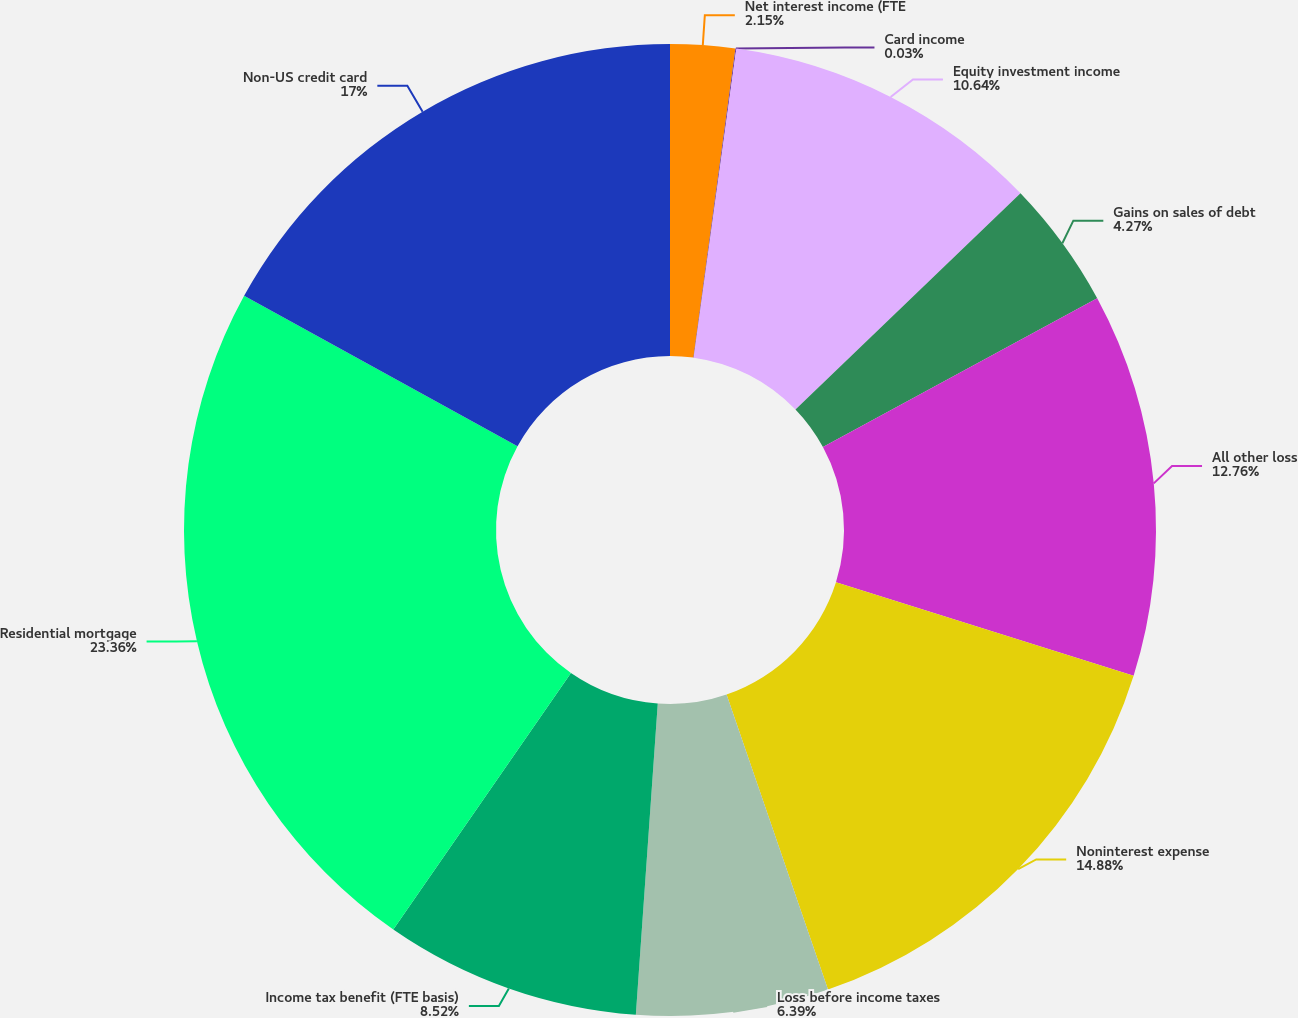Convert chart. <chart><loc_0><loc_0><loc_500><loc_500><pie_chart><fcel>Net interest income (FTE<fcel>Card income<fcel>Equity investment income<fcel>Gains on sales of debt<fcel>All other loss<fcel>Noninterest expense<fcel>Loss before income taxes<fcel>Income tax benefit (FTE basis)<fcel>Residential mortgage<fcel>Non-US credit card<nl><fcel>2.15%<fcel>0.03%<fcel>10.64%<fcel>4.27%<fcel>12.76%<fcel>14.88%<fcel>6.39%<fcel>8.52%<fcel>23.36%<fcel>17.0%<nl></chart> 